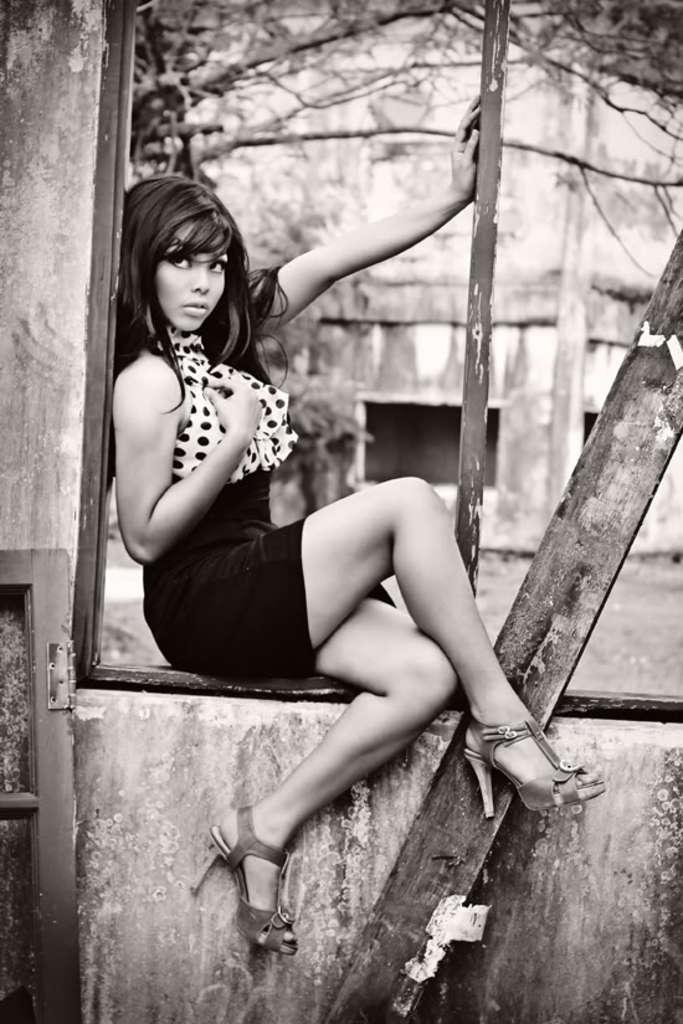What is the color scheme of the image? The image is black and white. What is the girl doing in the image? The girl is sitting on the window door. What type of objects can be seen at the bottom of the image? There are wooden objects at the bottom of the image. What can be seen in the background of the image? There is a tree and a building in the background of the image. Can you see any parents in the image? There is no reference to parents in the image, so it is not possible to determine if any are present. 